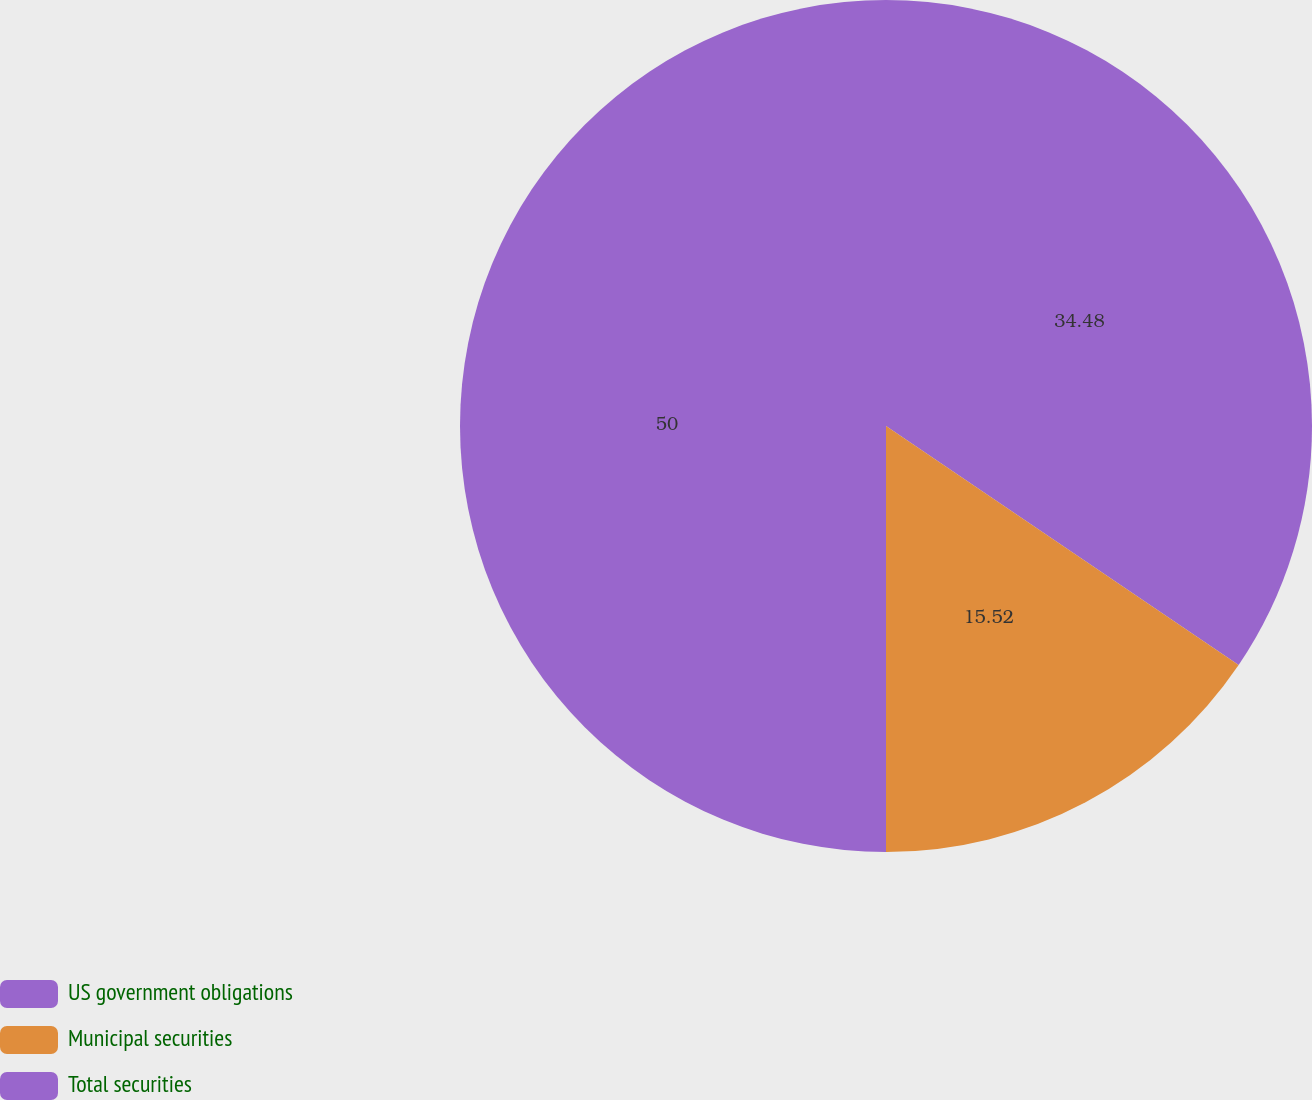Convert chart. <chart><loc_0><loc_0><loc_500><loc_500><pie_chart><fcel>US government obligations<fcel>Municipal securities<fcel>Total securities<nl><fcel>34.48%<fcel>15.52%<fcel>50.0%<nl></chart> 